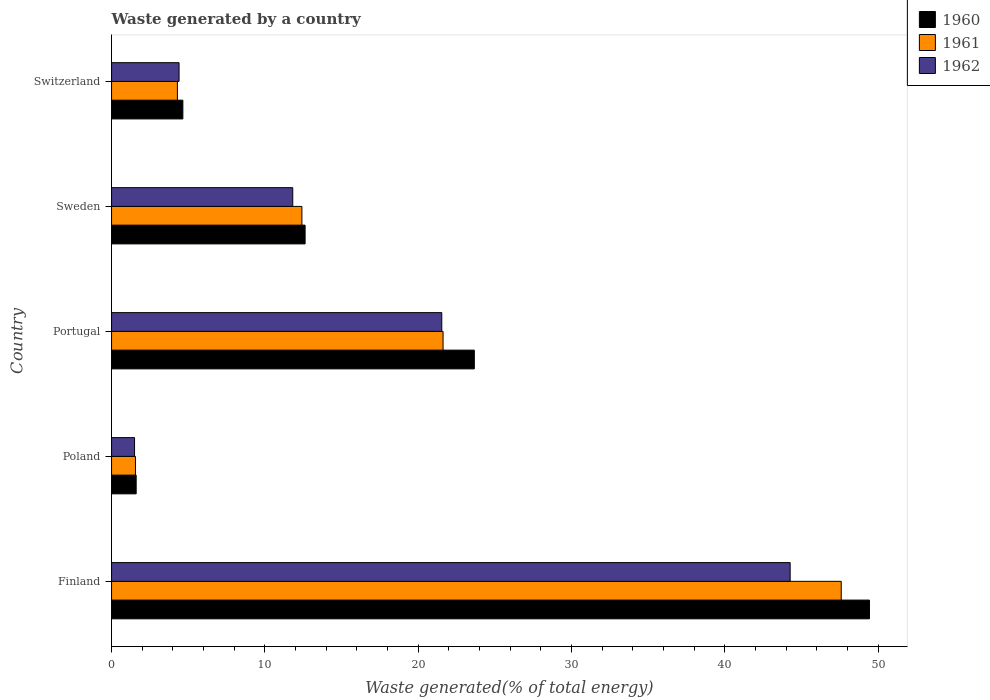How many different coloured bars are there?
Give a very brief answer. 3. Are the number of bars per tick equal to the number of legend labels?
Provide a succinct answer. Yes. How many bars are there on the 2nd tick from the top?
Provide a succinct answer. 3. What is the label of the 2nd group of bars from the top?
Offer a very short reply. Sweden. What is the total waste generated in 1961 in Switzerland?
Keep it short and to the point. 4.29. Across all countries, what is the maximum total waste generated in 1960?
Make the answer very short. 49.42. Across all countries, what is the minimum total waste generated in 1961?
Make the answer very short. 1.56. What is the total total waste generated in 1960 in the graph?
Provide a short and direct response. 91.96. What is the difference between the total waste generated in 1962 in Portugal and that in Switzerland?
Keep it short and to the point. 17.13. What is the difference between the total waste generated in 1960 in Finland and the total waste generated in 1962 in Portugal?
Offer a terse response. 27.89. What is the average total waste generated in 1960 per country?
Offer a terse response. 18.39. What is the difference between the total waste generated in 1962 and total waste generated in 1960 in Sweden?
Your answer should be very brief. -0.81. In how many countries, is the total waste generated in 1962 greater than 26 %?
Your response must be concise. 1. What is the ratio of the total waste generated in 1961 in Finland to that in Switzerland?
Provide a short and direct response. 11.09. What is the difference between the highest and the second highest total waste generated in 1961?
Ensure brevity in your answer.  25.96. What is the difference between the highest and the lowest total waste generated in 1962?
Give a very brief answer. 42.75. In how many countries, is the total waste generated in 1962 greater than the average total waste generated in 1962 taken over all countries?
Offer a very short reply. 2. Is the sum of the total waste generated in 1960 in Poland and Sweden greater than the maximum total waste generated in 1962 across all countries?
Provide a succinct answer. No. What does the 3rd bar from the top in Portugal represents?
Offer a very short reply. 1960. Are all the bars in the graph horizontal?
Offer a terse response. Yes. What is the difference between two consecutive major ticks on the X-axis?
Your response must be concise. 10. Are the values on the major ticks of X-axis written in scientific E-notation?
Keep it short and to the point. No. Does the graph contain any zero values?
Your answer should be very brief. No. Does the graph contain grids?
Your response must be concise. No. How are the legend labels stacked?
Provide a short and direct response. Vertical. What is the title of the graph?
Your answer should be very brief. Waste generated by a country. What is the label or title of the X-axis?
Make the answer very short. Waste generated(% of total energy). What is the label or title of the Y-axis?
Make the answer very short. Country. What is the Waste generated(% of total energy) of 1960 in Finland?
Give a very brief answer. 49.42. What is the Waste generated(% of total energy) of 1961 in Finland?
Your answer should be very brief. 47.58. What is the Waste generated(% of total energy) of 1962 in Finland?
Make the answer very short. 44.25. What is the Waste generated(% of total energy) in 1960 in Poland?
Provide a succinct answer. 1.6. What is the Waste generated(% of total energy) in 1961 in Poland?
Your answer should be very brief. 1.56. What is the Waste generated(% of total energy) of 1962 in Poland?
Your answer should be compact. 1.5. What is the Waste generated(% of total energy) in 1960 in Portugal?
Your answer should be very brief. 23.66. What is the Waste generated(% of total energy) of 1961 in Portugal?
Provide a succinct answer. 21.62. What is the Waste generated(% of total energy) of 1962 in Portugal?
Offer a terse response. 21.53. What is the Waste generated(% of total energy) of 1960 in Sweden?
Offer a terse response. 12.62. What is the Waste generated(% of total energy) of 1961 in Sweden?
Your answer should be very brief. 12.41. What is the Waste generated(% of total energy) in 1962 in Sweden?
Ensure brevity in your answer.  11.82. What is the Waste generated(% of total energy) in 1960 in Switzerland?
Make the answer very short. 4.65. What is the Waste generated(% of total energy) in 1961 in Switzerland?
Offer a very short reply. 4.29. What is the Waste generated(% of total energy) in 1962 in Switzerland?
Ensure brevity in your answer.  4.4. Across all countries, what is the maximum Waste generated(% of total energy) in 1960?
Give a very brief answer. 49.42. Across all countries, what is the maximum Waste generated(% of total energy) in 1961?
Your answer should be compact. 47.58. Across all countries, what is the maximum Waste generated(% of total energy) of 1962?
Offer a very short reply. 44.25. Across all countries, what is the minimum Waste generated(% of total energy) of 1960?
Provide a short and direct response. 1.6. Across all countries, what is the minimum Waste generated(% of total energy) in 1961?
Give a very brief answer. 1.56. Across all countries, what is the minimum Waste generated(% of total energy) of 1962?
Keep it short and to the point. 1.5. What is the total Waste generated(% of total energy) in 1960 in the graph?
Provide a short and direct response. 91.96. What is the total Waste generated(% of total energy) in 1961 in the graph?
Provide a short and direct response. 87.46. What is the total Waste generated(% of total energy) of 1962 in the graph?
Give a very brief answer. 83.5. What is the difference between the Waste generated(% of total energy) of 1960 in Finland and that in Poland?
Offer a very short reply. 47.82. What is the difference between the Waste generated(% of total energy) of 1961 in Finland and that in Poland?
Make the answer very short. 46.02. What is the difference between the Waste generated(% of total energy) of 1962 in Finland and that in Poland?
Give a very brief answer. 42.75. What is the difference between the Waste generated(% of total energy) in 1960 in Finland and that in Portugal?
Keep it short and to the point. 25.77. What is the difference between the Waste generated(% of total energy) in 1961 in Finland and that in Portugal?
Make the answer very short. 25.96. What is the difference between the Waste generated(% of total energy) of 1962 in Finland and that in Portugal?
Make the answer very short. 22.72. What is the difference between the Waste generated(% of total energy) in 1960 in Finland and that in Sweden?
Your response must be concise. 36.8. What is the difference between the Waste generated(% of total energy) of 1961 in Finland and that in Sweden?
Your answer should be very brief. 35.17. What is the difference between the Waste generated(% of total energy) of 1962 in Finland and that in Sweden?
Give a very brief answer. 32.44. What is the difference between the Waste generated(% of total energy) in 1960 in Finland and that in Switzerland?
Make the answer very short. 44.77. What is the difference between the Waste generated(% of total energy) in 1961 in Finland and that in Switzerland?
Your answer should be compact. 43.29. What is the difference between the Waste generated(% of total energy) in 1962 in Finland and that in Switzerland?
Give a very brief answer. 39.85. What is the difference between the Waste generated(% of total energy) of 1960 in Poland and that in Portugal?
Provide a succinct answer. -22.05. What is the difference between the Waste generated(% of total energy) in 1961 in Poland and that in Portugal?
Make the answer very short. -20.06. What is the difference between the Waste generated(% of total energy) in 1962 in Poland and that in Portugal?
Provide a succinct answer. -20.03. What is the difference between the Waste generated(% of total energy) in 1960 in Poland and that in Sweden?
Offer a terse response. -11.02. What is the difference between the Waste generated(% of total energy) in 1961 in Poland and that in Sweden?
Offer a very short reply. -10.85. What is the difference between the Waste generated(% of total energy) of 1962 in Poland and that in Sweden?
Your answer should be compact. -10.32. What is the difference between the Waste generated(% of total energy) of 1960 in Poland and that in Switzerland?
Offer a terse response. -3.04. What is the difference between the Waste generated(% of total energy) in 1961 in Poland and that in Switzerland?
Keep it short and to the point. -2.73. What is the difference between the Waste generated(% of total energy) of 1962 in Poland and that in Switzerland?
Give a very brief answer. -2.9. What is the difference between the Waste generated(% of total energy) in 1960 in Portugal and that in Sweden?
Offer a terse response. 11.03. What is the difference between the Waste generated(% of total energy) of 1961 in Portugal and that in Sweden?
Offer a terse response. 9.2. What is the difference between the Waste generated(% of total energy) of 1962 in Portugal and that in Sweden?
Your answer should be compact. 9.72. What is the difference between the Waste generated(% of total energy) in 1960 in Portugal and that in Switzerland?
Offer a very short reply. 19.01. What is the difference between the Waste generated(% of total energy) of 1961 in Portugal and that in Switzerland?
Give a very brief answer. 17.32. What is the difference between the Waste generated(% of total energy) of 1962 in Portugal and that in Switzerland?
Keep it short and to the point. 17.13. What is the difference between the Waste generated(% of total energy) of 1960 in Sweden and that in Switzerland?
Your answer should be compact. 7.97. What is the difference between the Waste generated(% of total energy) in 1961 in Sweden and that in Switzerland?
Provide a succinct answer. 8.12. What is the difference between the Waste generated(% of total energy) in 1962 in Sweden and that in Switzerland?
Offer a very short reply. 7.41. What is the difference between the Waste generated(% of total energy) of 1960 in Finland and the Waste generated(% of total energy) of 1961 in Poland?
Provide a short and direct response. 47.86. What is the difference between the Waste generated(% of total energy) of 1960 in Finland and the Waste generated(% of total energy) of 1962 in Poland?
Make the answer very short. 47.92. What is the difference between the Waste generated(% of total energy) in 1961 in Finland and the Waste generated(% of total energy) in 1962 in Poland?
Provide a short and direct response. 46.08. What is the difference between the Waste generated(% of total energy) of 1960 in Finland and the Waste generated(% of total energy) of 1961 in Portugal?
Ensure brevity in your answer.  27.81. What is the difference between the Waste generated(% of total energy) in 1960 in Finland and the Waste generated(% of total energy) in 1962 in Portugal?
Offer a terse response. 27.89. What is the difference between the Waste generated(% of total energy) in 1961 in Finland and the Waste generated(% of total energy) in 1962 in Portugal?
Offer a terse response. 26.05. What is the difference between the Waste generated(% of total energy) in 1960 in Finland and the Waste generated(% of total energy) in 1961 in Sweden?
Offer a very short reply. 37.01. What is the difference between the Waste generated(% of total energy) of 1960 in Finland and the Waste generated(% of total energy) of 1962 in Sweden?
Offer a very short reply. 37.61. What is the difference between the Waste generated(% of total energy) in 1961 in Finland and the Waste generated(% of total energy) in 1962 in Sweden?
Provide a short and direct response. 35.77. What is the difference between the Waste generated(% of total energy) in 1960 in Finland and the Waste generated(% of total energy) in 1961 in Switzerland?
Your answer should be very brief. 45.13. What is the difference between the Waste generated(% of total energy) in 1960 in Finland and the Waste generated(% of total energy) in 1962 in Switzerland?
Ensure brevity in your answer.  45.02. What is the difference between the Waste generated(% of total energy) of 1961 in Finland and the Waste generated(% of total energy) of 1962 in Switzerland?
Make the answer very short. 43.18. What is the difference between the Waste generated(% of total energy) of 1960 in Poland and the Waste generated(% of total energy) of 1961 in Portugal?
Offer a terse response. -20.01. What is the difference between the Waste generated(% of total energy) in 1960 in Poland and the Waste generated(% of total energy) in 1962 in Portugal?
Ensure brevity in your answer.  -19.93. What is the difference between the Waste generated(% of total energy) of 1961 in Poland and the Waste generated(% of total energy) of 1962 in Portugal?
Your answer should be very brief. -19.98. What is the difference between the Waste generated(% of total energy) in 1960 in Poland and the Waste generated(% of total energy) in 1961 in Sweden?
Your answer should be very brief. -10.81. What is the difference between the Waste generated(% of total energy) in 1960 in Poland and the Waste generated(% of total energy) in 1962 in Sweden?
Provide a short and direct response. -10.21. What is the difference between the Waste generated(% of total energy) in 1961 in Poland and the Waste generated(% of total energy) in 1962 in Sweden?
Offer a very short reply. -10.26. What is the difference between the Waste generated(% of total energy) in 1960 in Poland and the Waste generated(% of total energy) in 1961 in Switzerland?
Keep it short and to the point. -2.69. What is the difference between the Waste generated(% of total energy) of 1960 in Poland and the Waste generated(% of total energy) of 1962 in Switzerland?
Your response must be concise. -2.8. What is the difference between the Waste generated(% of total energy) of 1961 in Poland and the Waste generated(% of total energy) of 1962 in Switzerland?
Provide a short and direct response. -2.84. What is the difference between the Waste generated(% of total energy) in 1960 in Portugal and the Waste generated(% of total energy) in 1961 in Sweden?
Your answer should be very brief. 11.24. What is the difference between the Waste generated(% of total energy) of 1960 in Portugal and the Waste generated(% of total energy) of 1962 in Sweden?
Ensure brevity in your answer.  11.84. What is the difference between the Waste generated(% of total energy) in 1961 in Portugal and the Waste generated(% of total energy) in 1962 in Sweden?
Make the answer very short. 9.8. What is the difference between the Waste generated(% of total energy) of 1960 in Portugal and the Waste generated(% of total energy) of 1961 in Switzerland?
Your answer should be very brief. 19.36. What is the difference between the Waste generated(% of total energy) of 1960 in Portugal and the Waste generated(% of total energy) of 1962 in Switzerland?
Your response must be concise. 19.25. What is the difference between the Waste generated(% of total energy) of 1961 in Portugal and the Waste generated(% of total energy) of 1962 in Switzerland?
Keep it short and to the point. 17.21. What is the difference between the Waste generated(% of total energy) of 1960 in Sweden and the Waste generated(% of total energy) of 1961 in Switzerland?
Give a very brief answer. 8.33. What is the difference between the Waste generated(% of total energy) in 1960 in Sweden and the Waste generated(% of total energy) in 1962 in Switzerland?
Make the answer very short. 8.22. What is the difference between the Waste generated(% of total energy) in 1961 in Sweden and the Waste generated(% of total energy) in 1962 in Switzerland?
Your response must be concise. 8.01. What is the average Waste generated(% of total energy) in 1960 per country?
Provide a succinct answer. 18.39. What is the average Waste generated(% of total energy) in 1961 per country?
Make the answer very short. 17.49. What is the average Waste generated(% of total energy) of 1962 per country?
Ensure brevity in your answer.  16.7. What is the difference between the Waste generated(% of total energy) of 1960 and Waste generated(% of total energy) of 1961 in Finland?
Give a very brief answer. 1.84. What is the difference between the Waste generated(% of total energy) in 1960 and Waste generated(% of total energy) in 1962 in Finland?
Ensure brevity in your answer.  5.17. What is the difference between the Waste generated(% of total energy) of 1961 and Waste generated(% of total energy) of 1962 in Finland?
Offer a terse response. 3.33. What is the difference between the Waste generated(% of total energy) in 1960 and Waste generated(% of total energy) in 1961 in Poland?
Ensure brevity in your answer.  0.05. What is the difference between the Waste generated(% of total energy) in 1960 and Waste generated(% of total energy) in 1962 in Poland?
Your response must be concise. 0.11. What is the difference between the Waste generated(% of total energy) of 1961 and Waste generated(% of total energy) of 1962 in Poland?
Your response must be concise. 0.06. What is the difference between the Waste generated(% of total energy) in 1960 and Waste generated(% of total energy) in 1961 in Portugal?
Make the answer very short. 2.04. What is the difference between the Waste generated(% of total energy) of 1960 and Waste generated(% of total energy) of 1962 in Portugal?
Ensure brevity in your answer.  2.12. What is the difference between the Waste generated(% of total energy) of 1961 and Waste generated(% of total energy) of 1962 in Portugal?
Ensure brevity in your answer.  0.08. What is the difference between the Waste generated(% of total energy) of 1960 and Waste generated(% of total energy) of 1961 in Sweden?
Offer a terse response. 0.21. What is the difference between the Waste generated(% of total energy) in 1960 and Waste generated(% of total energy) in 1962 in Sweden?
Make the answer very short. 0.81. What is the difference between the Waste generated(% of total energy) of 1961 and Waste generated(% of total energy) of 1962 in Sweden?
Provide a short and direct response. 0.6. What is the difference between the Waste generated(% of total energy) in 1960 and Waste generated(% of total energy) in 1961 in Switzerland?
Your response must be concise. 0.36. What is the difference between the Waste generated(% of total energy) in 1960 and Waste generated(% of total energy) in 1962 in Switzerland?
Make the answer very short. 0.25. What is the difference between the Waste generated(% of total energy) of 1961 and Waste generated(% of total energy) of 1962 in Switzerland?
Your response must be concise. -0.11. What is the ratio of the Waste generated(% of total energy) of 1960 in Finland to that in Poland?
Provide a short and direct response. 30.8. What is the ratio of the Waste generated(% of total energy) in 1961 in Finland to that in Poland?
Your answer should be very brief. 30.53. What is the ratio of the Waste generated(% of total energy) of 1962 in Finland to that in Poland?
Your response must be concise. 29.52. What is the ratio of the Waste generated(% of total energy) of 1960 in Finland to that in Portugal?
Your response must be concise. 2.09. What is the ratio of the Waste generated(% of total energy) of 1961 in Finland to that in Portugal?
Your answer should be very brief. 2.2. What is the ratio of the Waste generated(% of total energy) in 1962 in Finland to that in Portugal?
Make the answer very short. 2.05. What is the ratio of the Waste generated(% of total energy) in 1960 in Finland to that in Sweden?
Keep it short and to the point. 3.92. What is the ratio of the Waste generated(% of total energy) of 1961 in Finland to that in Sweden?
Offer a very short reply. 3.83. What is the ratio of the Waste generated(% of total energy) in 1962 in Finland to that in Sweden?
Give a very brief answer. 3.75. What is the ratio of the Waste generated(% of total energy) in 1960 in Finland to that in Switzerland?
Give a very brief answer. 10.63. What is the ratio of the Waste generated(% of total energy) in 1961 in Finland to that in Switzerland?
Give a very brief answer. 11.09. What is the ratio of the Waste generated(% of total energy) of 1962 in Finland to that in Switzerland?
Offer a very short reply. 10.05. What is the ratio of the Waste generated(% of total energy) in 1960 in Poland to that in Portugal?
Your response must be concise. 0.07. What is the ratio of the Waste generated(% of total energy) in 1961 in Poland to that in Portugal?
Give a very brief answer. 0.07. What is the ratio of the Waste generated(% of total energy) in 1962 in Poland to that in Portugal?
Ensure brevity in your answer.  0.07. What is the ratio of the Waste generated(% of total energy) of 1960 in Poland to that in Sweden?
Your response must be concise. 0.13. What is the ratio of the Waste generated(% of total energy) in 1961 in Poland to that in Sweden?
Give a very brief answer. 0.13. What is the ratio of the Waste generated(% of total energy) in 1962 in Poland to that in Sweden?
Provide a short and direct response. 0.13. What is the ratio of the Waste generated(% of total energy) of 1960 in Poland to that in Switzerland?
Make the answer very short. 0.35. What is the ratio of the Waste generated(% of total energy) in 1961 in Poland to that in Switzerland?
Offer a terse response. 0.36. What is the ratio of the Waste generated(% of total energy) in 1962 in Poland to that in Switzerland?
Keep it short and to the point. 0.34. What is the ratio of the Waste generated(% of total energy) in 1960 in Portugal to that in Sweden?
Offer a terse response. 1.87. What is the ratio of the Waste generated(% of total energy) in 1961 in Portugal to that in Sweden?
Make the answer very short. 1.74. What is the ratio of the Waste generated(% of total energy) of 1962 in Portugal to that in Sweden?
Offer a very short reply. 1.82. What is the ratio of the Waste generated(% of total energy) in 1960 in Portugal to that in Switzerland?
Your answer should be very brief. 5.09. What is the ratio of the Waste generated(% of total energy) in 1961 in Portugal to that in Switzerland?
Your answer should be very brief. 5.04. What is the ratio of the Waste generated(% of total energy) in 1962 in Portugal to that in Switzerland?
Provide a short and direct response. 4.89. What is the ratio of the Waste generated(% of total energy) of 1960 in Sweden to that in Switzerland?
Your response must be concise. 2.71. What is the ratio of the Waste generated(% of total energy) of 1961 in Sweden to that in Switzerland?
Ensure brevity in your answer.  2.89. What is the ratio of the Waste generated(% of total energy) of 1962 in Sweden to that in Switzerland?
Offer a terse response. 2.68. What is the difference between the highest and the second highest Waste generated(% of total energy) of 1960?
Your response must be concise. 25.77. What is the difference between the highest and the second highest Waste generated(% of total energy) in 1961?
Provide a short and direct response. 25.96. What is the difference between the highest and the second highest Waste generated(% of total energy) of 1962?
Offer a terse response. 22.72. What is the difference between the highest and the lowest Waste generated(% of total energy) in 1960?
Offer a terse response. 47.82. What is the difference between the highest and the lowest Waste generated(% of total energy) of 1961?
Your answer should be compact. 46.02. What is the difference between the highest and the lowest Waste generated(% of total energy) of 1962?
Offer a terse response. 42.75. 